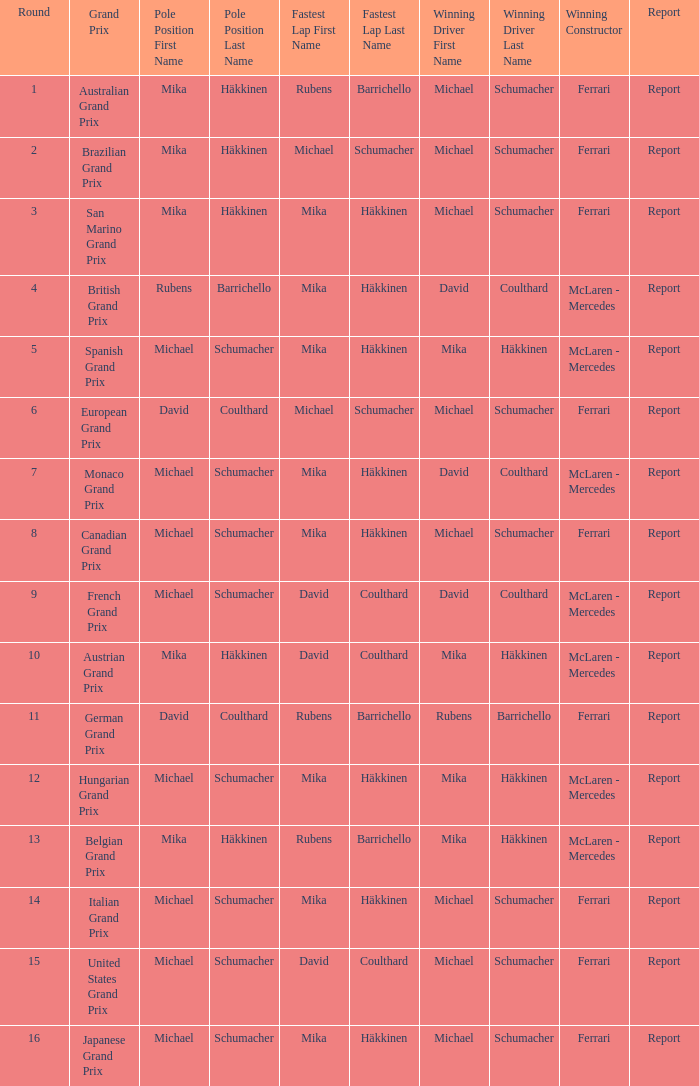How many racers claimed victory in the italian grand prix? 1.0. 